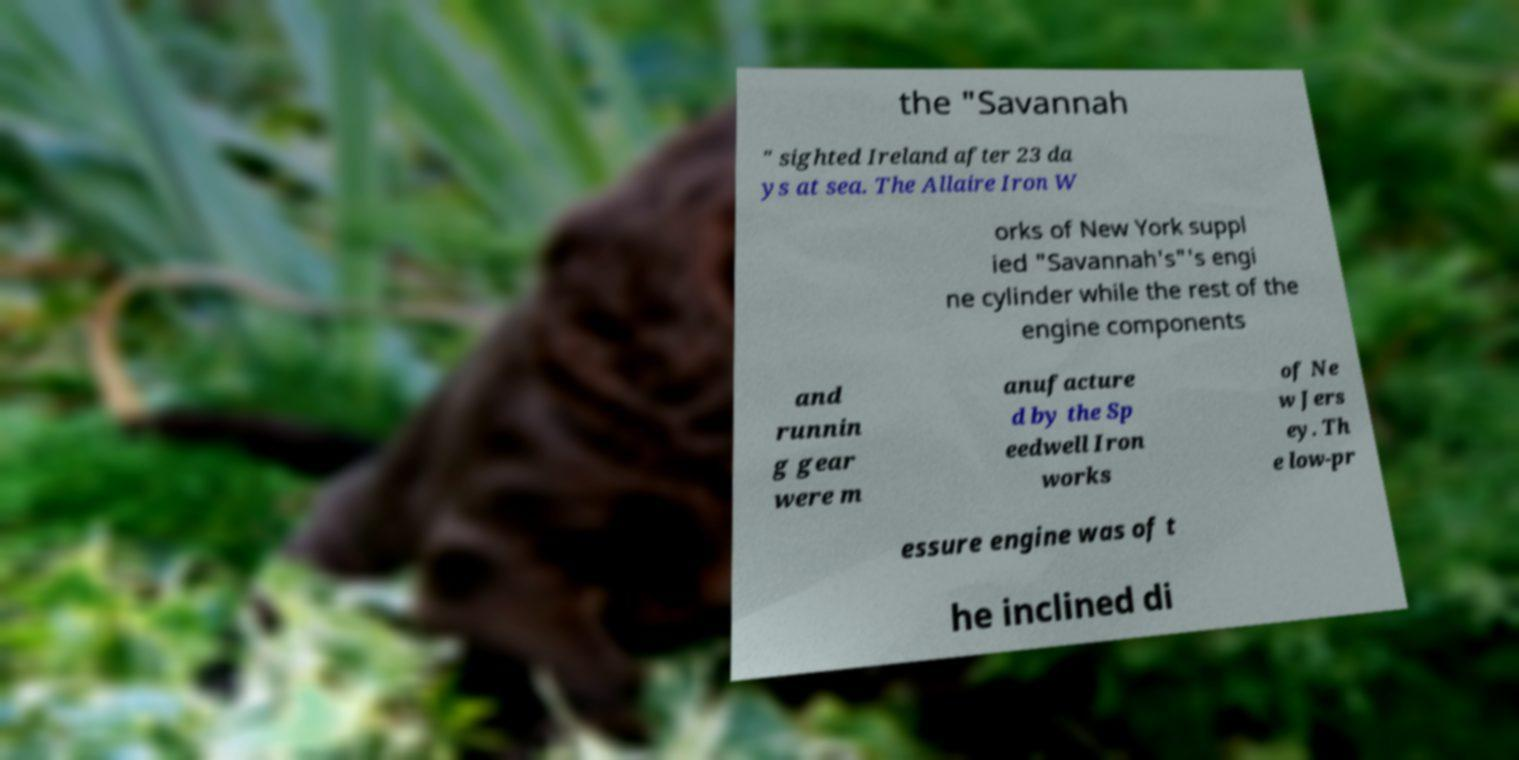What messages or text are displayed in this image? I need them in a readable, typed format. the "Savannah " sighted Ireland after 23 da ys at sea. The Allaire Iron W orks of New York suppl ied "Savannah's"'s engi ne cylinder while the rest of the engine components and runnin g gear were m anufacture d by the Sp eedwell Iron works of Ne w Jers ey. Th e low-pr essure engine was of t he inclined di 